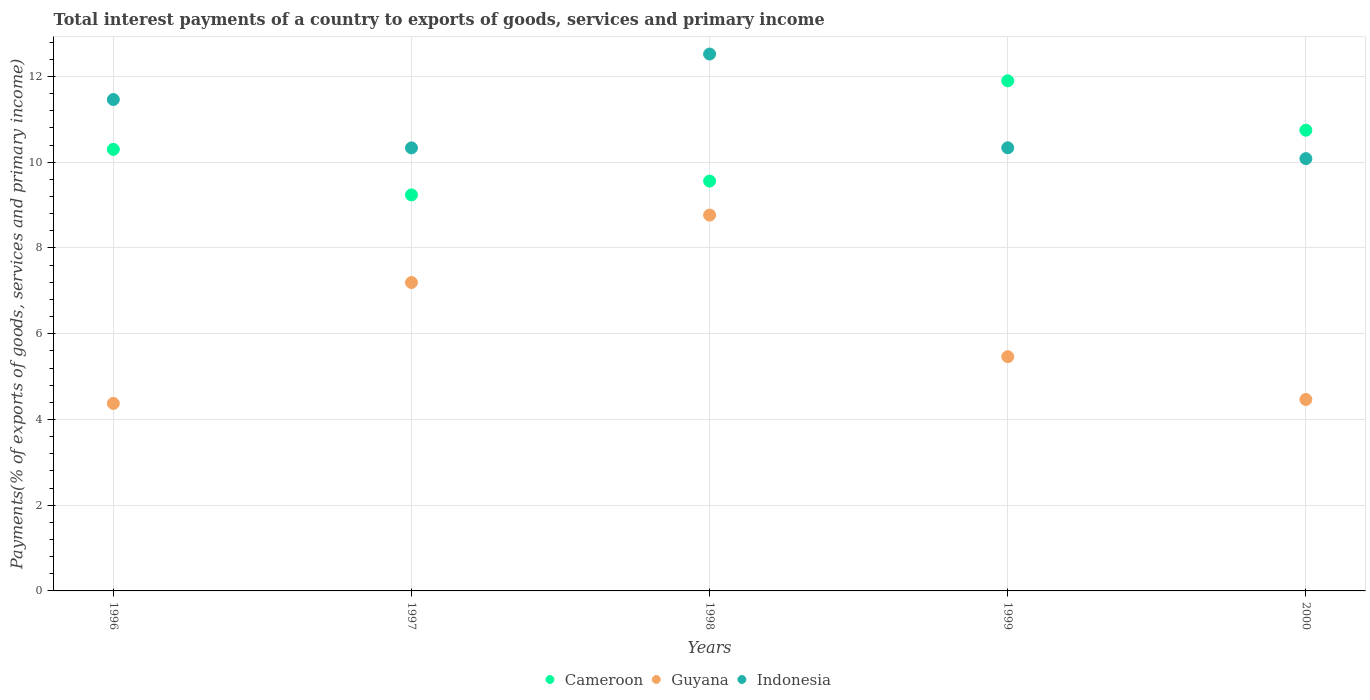How many different coloured dotlines are there?
Provide a short and direct response. 3. Is the number of dotlines equal to the number of legend labels?
Give a very brief answer. Yes. What is the total interest payments in Guyana in 2000?
Your response must be concise. 4.47. Across all years, what is the maximum total interest payments in Guyana?
Keep it short and to the point. 8.77. Across all years, what is the minimum total interest payments in Guyana?
Offer a very short reply. 4.37. What is the total total interest payments in Guyana in the graph?
Offer a very short reply. 30.27. What is the difference between the total interest payments in Indonesia in 1996 and that in 1999?
Provide a short and direct response. 1.13. What is the difference between the total interest payments in Guyana in 1998 and the total interest payments in Indonesia in 1996?
Your answer should be very brief. -2.7. What is the average total interest payments in Indonesia per year?
Your answer should be very brief. 10.95. In the year 1999, what is the difference between the total interest payments in Cameroon and total interest payments in Guyana?
Ensure brevity in your answer.  6.44. In how many years, is the total interest payments in Indonesia greater than 4 %?
Your response must be concise. 5. What is the ratio of the total interest payments in Indonesia in 1998 to that in 2000?
Keep it short and to the point. 1.24. What is the difference between the highest and the second highest total interest payments in Cameroon?
Offer a very short reply. 1.15. What is the difference between the highest and the lowest total interest payments in Indonesia?
Your response must be concise. 2.44. In how many years, is the total interest payments in Cameroon greater than the average total interest payments in Cameroon taken over all years?
Make the answer very short. 2. Is it the case that in every year, the sum of the total interest payments in Cameroon and total interest payments in Indonesia  is greater than the total interest payments in Guyana?
Offer a very short reply. Yes. Does the total interest payments in Indonesia monotonically increase over the years?
Keep it short and to the point. No. How many years are there in the graph?
Keep it short and to the point. 5. Are the values on the major ticks of Y-axis written in scientific E-notation?
Keep it short and to the point. No. Does the graph contain any zero values?
Offer a very short reply. No. How many legend labels are there?
Your answer should be compact. 3. What is the title of the graph?
Provide a succinct answer. Total interest payments of a country to exports of goods, services and primary income. What is the label or title of the Y-axis?
Offer a very short reply. Payments(% of exports of goods, services and primary income). What is the Payments(% of exports of goods, services and primary income) in Cameroon in 1996?
Provide a short and direct response. 10.3. What is the Payments(% of exports of goods, services and primary income) in Guyana in 1996?
Provide a short and direct response. 4.37. What is the Payments(% of exports of goods, services and primary income) in Indonesia in 1996?
Keep it short and to the point. 11.46. What is the Payments(% of exports of goods, services and primary income) in Cameroon in 1997?
Give a very brief answer. 9.24. What is the Payments(% of exports of goods, services and primary income) in Guyana in 1997?
Provide a short and direct response. 7.19. What is the Payments(% of exports of goods, services and primary income) of Indonesia in 1997?
Provide a short and direct response. 10.34. What is the Payments(% of exports of goods, services and primary income) of Cameroon in 1998?
Provide a succinct answer. 9.56. What is the Payments(% of exports of goods, services and primary income) in Guyana in 1998?
Your response must be concise. 8.77. What is the Payments(% of exports of goods, services and primary income) of Indonesia in 1998?
Offer a terse response. 12.52. What is the Payments(% of exports of goods, services and primary income) in Cameroon in 1999?
Provide a succinct answer. 11.9. What is the Payments(% of exports of goods, services and primary income) of Guyana in 1999?
Your answer should be very brief. 5.46. What is the Payments(% of exports of goods, services and primary income) of Indonesia in 1999?
Offer a very short reply. 10.34. What is the Payments(% of exports of goods, services and primary income) in Cameroon in 2000?
Your answer should be very brief. 10.75. What is the Payments(% of exports of goods, services and primary income) in Guyana in 2000?
Your answer should be very brief. 4.47. What is the Payments(% of exports of goods, services and primary income) in Indonesia in 2000?
Your answer should be compact. 10.08. Across all years, what is the maximum Payments(% of exports of goods, services and primary income) in Cameroon?
Give a very brief answer. 11.9. Across all years, what is the maximum Payments(% of exports of goods, services and primary income) of Guyana?
Give a very brief answer. 8.77. Across all years, what is the maximum Payments(% of exports of goods, services and primary income) in Indonesia?
Offer a terse response. 12.52. Across all years, what is the minimum Payments(% of exports of goods, services and primary income) of Cameroon?
Keep it short and to the point. 9.24. Across all years, what is the minimum Payments(% of exports of goods, services and primary income) in Guyana?
Your response must be concise. 4.37. Across all years, what is the minimum Payments(% of exports of goods, services and primary income) in Indonesia?
Make the answer very short. 10.08. What is the total Payments(% of exports of goods, services and primary income) of Cameroon in the graph?
Keep it short and to the point. 51.74. What is the total Payments(% of exports of goods, services and primary income) of Guyana in the graph?
Your answer should be very brief. 30.27. What is the total Payments(% of exports of goods, services and primary income) of Indonesia in the graph?
Give a very brief answer. 54.74. What is the difference between the Payments(% of exports of goods, services and primary income) of Cameroon in 1996 and that in 1997?
Make the answer very short. 1.06. What is the difference between the Payments(% of exports of goods, services and primary income) in Guyana in 1996 and that in 1997?
Give a very brief answer. -2.82. What is the difference between the Payments(% of exports of goods, services and primary income) in Indonesia in 1996 and that in 1997?
Your response must be concise. 1.13. What is the difference between the Payments(% of exports of goods, services and primary income) in Cameroon in 1996 and that in 1998?
Offer a very short reply. 0.74. What is the difference between the Payments(% of exports of goods, services and primary income) in Guyana in 1996 and that in 1998?
Offer a terse response. -4.39. What is the difference between the Payments(% of exports of goods, services and primary income) of Indonesia in 1996 and that in 1998?
Offer a terse response. -1.06. What is the difference between the Payments(% of exports of goods, services and primary income) of Cameroon in 1996 and that in 1999?
Give a very brief answer. -1.6. What is the difference between the Payments(% of exports of goods, services and primary income) in Guyana in 1996 and that in 1999?
Give a very brief answer. -1.09. What is the difference between the Payments(% of exports of goods, services and primary income) of Indonesia in 1996 and that in 1999?
Give a very brief answer. 1.13. What is the difference between the Payments(% of exports of goods, services and primary income) in Cameroon in 1996 and that in 2000?
Ensure brevity in your answer.  -0.45. What is the difference between the Payments(% of exports of goods, services and primary income) in Guyana in 1996 and that in 2000?
Your response must be concise. -0.09. What is the difference between the Payments(% of exports of goods, services and primary income) in Indonesia in 1996 and that in 2000?
Offer a very short reply. 1.38. What is the difference between the Payments(% of exports of goods, services and primary income) of Cameroon in 1997 and that in 1998?
Provide a succinct answer. -0.32. What is the difference between the Payments(% of exports of goods, services and primary income) in Guyana in 1997 and that in 1998?
Provide a succinct answer. -1.57. What is the difference between the Payments(% of exports of goods, services and primary income) in Indonesia in 1997 and that in 1998?
Keep it short and to the point. -2.19. What is the difference between the Payments(% of exports of goods, services and primary income) in Cameroon in 1997 and that in 1999?
Provide a succinct answer. -2.66. What is the difference between the Payments(% of exports of goods, services and primary income) in Guyana in 1997 and that in 1999?
Provide a succinct answer. 1.73. What is the difference between the Payments(% of exports of goods, services and primary income) of Indonesia in 1997 and that in 1999?
Offer a very short reply. -0. What is the difference between the Payments(% of exports of goods, services and primary income) in Cameroon in 1997 and that in 2000?
Provide a short and direct response. -1.51. What is the difference between the Payments(% of exports of goods, services and primary income) in Guyana in 1997 and that in 2000?
Your response must be concise. 2.73. What is the difference between the Payments(% of exports of goods, services and primary income) of Indonesia in 1997 and that in 2000?
Your answer should be very brief. 0.25. What is the difference between the Payments(% of exports of goods, services and primary income) of Cameroon in 1998 and that in 1999?
Offer a terse response. -2.34. What is the difference between the Payments(% of exports of goods, services and primary income) in Guyana in 1998 and that in 1999?
Give a very brief answer. 3.3. What is the difference between the Payments(% of exports of goods, services and primary income) of Indonesia in 1998 and that in 1999?
Provide a short and direct response. 2.19. What is the difference between the Payments(% of exports of goods, services and primary income) of Cameroon in 1998 and that in 2000?
Your response must be concise. -1.19. What is the difference between the Payments(% of exports of goods, services and primary income) in Guyana in 1998 and that in 2000?
Your answer should be very brief. 4.3. What is the difference between the Payments(% of exports of goods, services and primary income) of Indonesia in 1998 and that in 2000?
Offer a terse response. 2.44. What is the difference between the Payments(% of exports of goods, services and primary income) of Cameroon in 1999 and that in 2000?
Offer a terse response. 1.15. What is the difference between the Payments(% of exports of goods, services and primary income) of Guyana in 1999 and that in 2000?
Your response must be concise. 1. What is the difference between the Payments(% of exports of goods, services and primary income) in Indonesia in 1999 and that in 2000?
Keep it short and to the point. 0.25. What is the difference between the Payments(% of exports of goods, services and primary income) in Cameroon in 1996 and the Payments(% of exports of goods, services and primary income) in Guyana in 1997?
Keep it short and to the point. 3.11. What is the difference between the Payments(% of exports of goods, services and primary income) of Cameroon in 1996 and the Payments(% of exports of goods, services and primary income) of Indonesia in 1997?
Keep it short and to the point. -0.03. What is the difference between the Payments(% of exports of goods, services and primary income) in Guyana in 1996 and the Payments(% of exports of goods, services and primary income) in Indonesia in 1997?
Your answer should be very brief. -5.96. What is the difference between the Payments(% of exports of goods, services and primary income) in Cameroon in 1996 and the Payments(% of exports of goods, services and primary income) in Guyana in 1998?
Make the answer very short. 1.53. What is the difference between the Payments(% of exports of goods, services and primary income) of Cameroon in 1996 and the Payments(% of exports of goods, services and primary income) of Indonesia in 1998?
Your answer should be compact. -2.22. What is the difference between the Payments(% of exports of goods, services and primary income) in Guyana in 1996 and the Payments(% of exports of goods, services and primary income) in Indonesia in 1998?
Provide a short and direct response. -8.15. What is the difference between the Payments(% of exports of goods, services and primary income) in Cameroon in 1996 and the Payments(% of exports of goods, services and primary income) in Guyana in 1999?
Your answer should be very brief. 4.84. What is the difference between the Payments(% of exports of goods, services and primary income) in Cameroon in 1996 and the Payments(% of exports of goods, services and primary income) in Indonesia in 1999?
Your answer should be compact. -0.04. What is the difference between the Payments(% of exports of goods, services and primary income) in Guyana in 1996 and the Payments(% of exports of goods, services and primary income) in Indonesia in 1999?
Keep it short and to the point. -5.96. What is the difference between the Payments(% of exports of goods, services and primary income) in Cameroon in 1996 and the Payments(% of exports of goods, services and primary income) in Guyana in 2000?
Offer a terse response. 5.83. What is the difference between the Payments(% of exports of goods, services and primary income) of Cameroon in 1996 and the Payments(% of exports of goods, services and primary income) of Indonesia in 2000?
Give a very brief answer. 0.22. What is the difference between the Payments(% of exports of goods, services and primary income) of Guyana in 1996 and the Payments(% of exports of goods, services and primary income) of Indonesia in 2000?
Your answer should be very brief. -5.71. What is the difference between the Payments(% of exports of goods, services and primary income) in Cameroon in 1997 and the Payments(% of exports of goods, services and primary income) in Guyana in 1998?
Offer a terse response. 0.47. What is the difference between the Payments(% of exports of goods, services and primary income) in Cameroon in 1997 and the Payments(% of exports of goods, services and primary income) in Indonesia in 1998?
Your answer should be very brief. -3.29. What is the difference between the Payments(% of exports of goods, services and primary income) of Guyana in 1997 and the Payments(% of exports of goods, services and primary income) of Indonesia in 1998?
Ensure brevity in your answer.  -5.33. What is the difference between the Payments(% of exports of goods, services and primary income) in Cameroon in 1997 and the Payments(% of exports of goods, services and primary income) in Guyana in 1999?
Offer a terse response. 3.77. What is the difference between the Payments(% of exports of goods, services and primary income) in Cameroon in 1997 and the Payments(% of exports of goods, services and primary income) in Indonesia in 1999?
Provide a succinct answer. -1.1. What is the difference between the Payments(% of exports of goods, services and primary income) in Guyana in 1997 and the Payments(% of exports of goods, services and primary income) in Indonesia in 1999?
Offer a very short reply. -3.14. What is the difference between the Payments(% of exports of goods, services and primary income) in Cameroon in 1997 and the Payments(% of exports of goods, services and primary income) in Guyana in 2000?
Your answer should be compact. 4.77. What is the difference between the Payments(% of exports of goods, services and primary income) in Cameroon in 1997 and the Payments(% of exports of goods, services and primary income) in Indonesia in 2000?
Your answer should be very brief. -0.85. What is the difference between the Payments(% of exports of goods, services and primary income) in Guyana in 1997 and the Payments(% of exports of goods, services and primary income) in Indonesia in 2000?
Keep it short and to the point. -2.89. What is the difference between the Payments(% of exports of goods, services and primary income) of Cameroon in 1998 and the Payments(% of exports of goods, services and primary income) of Guyana in 1999?
Provide a short and direct response. 4.1. What is the difference between the Payments(% of exports of goods, services and primary income) in Cameroon in 1998 and the Payments(% of exports of goods, services and primary income) in Indonesia in 1999?
Your answer should be compact. -0.78. What is the difference between the Payments(% of exports of goods, services and primary income) in Guyana in 1998 and the Payments(% of exports of goods, services and primary income) in Indonesia in 1999?
Provide a succinct answer. -1.57. What is the difference between the Payments(% of exports of goods, services and primary income) in Cameroon in 1998 and the Payments(% of exports of goods, services and primary income) in Guyana in 2000?
Your response must be concise. 5.09. What is the difference between the Payments(% of exports of goods, services and primary income) of Cameroon in 1998 and the Payments(% of exports of goods, services and primary income) of Indonesia in 2000?
Your response must be concise. -0.52. What is the difference between the Payments(% of exports of goods, services and primary income) of Guyana in 1998 and the Payments(% of exports of goods, services and primary income) of Indonesia in 2000?
Give a very brief answer. -1.32. What is the difference between the Payments(% of exports of goods, services and primary income) of Cameroon in 1999 and the Payments(% of exports of goods, services and primary income) of Guyana in 2000?
Make the answer very short. 7.43. What is the difference between the Payments(% of exports of goods, services and primary income) in Cameroon in 1999 and the Payments(% of exports of goods, services and primary income) in Indonesia in 2000?
Your answer should be very brief. 1.81. What is the difference between the Payments(% of exports of goods, services and primary income) of Guyana in 1999 and the Payments(% of exports of goods, services and primary income) of Indonesia in 2000?
Make the answer very short. -4.62. What is the average Payments(% of exports of goods, services and primary income) in Cameroon per year?
Your answer should be very brief. 10.35. What is the average Payments(% of exports of goods, services and primary income) of Guyana per year?
Give a very brief answer. 6.05. What is the average Payments(% of exports of goods, services and primary income) in Indonesia per year?
Your answer should be compact. 10.95. In the year 1996, what is the difference between the Payments(% of exports of goods, services and primary income) in Cameroon and Payments(% of exports of goods, services and primary income) in Guyana?
Your response must be concise. 5.93. In the year 1996, what is the difference between the Payments(% of exports of goods, services and primary income) of Cameroon and Payments(% of exports of goods, services and primary income) of Indonesia?
Give a very brief answer. -1.16. In the year 1996, what is the difference between the Payments(% of exports of goods, services and primary income) in Guyana and Payments(% of exports of goods, services and primary income) in Indonesia?
Offer a terse response. -7.09. In the year 1997, what is the difference between the Payments(% of exports of goods, services and primary income) in Cameroon and Payments(% of exports of goods, services and primary income) in Guyana?
Your answer should be very brief. 2.04. In the year 1997, what is the difference between the Payments(% of exports of goods, services and primary income) of Cameroon and Payments(% of exports of goods, services and primary income) of Indonesia?
Offer a very short reply. -1.1. In the year 1997, what is the difference between the Payments(% of exports of goods, services and primary income) in Guyana and Payments(% of exports of goods, services and primary income) in Indonesia?
Your response must be concise. -3.14. In the year 1998, what is the difference between the Payments(% of exports of goods, services and primary income) of Cameroon and Payments(% of exports of goods, services and primary income) of Guyana?
Your answer should be very brief. 0.79. In the year 1998, what is the difference between the Payments(% of exports of goods, services and primary income) of Cameroon and Payments(% of exports of goods, services and primary income) of Indonesia?
Ensure brevity in your answer.  -2.96. In the year 1998, what is the difference between the Payments(% of exports of goods, services and primary income) of Guyana and Payments(% of exports of goods, services and primary income) of Indonesia?
Offer a very short reply. -3.76. In the year 1999, what is the difference between the Payments(% of exports of goods, services and primary income) of Cameroon and Payments(% of exports of goods, services and primary income) of Guyana?
Provide a succinct answer. 6.44. In the year 1999, what is the difference between the Payments(% of exports of goods, services and primary income) of Cameroon and Payments(% of exports of goods, services and primary income) of Indonesia?
Make the answer very short. 1.56. In the year 1999, what is the difference between the Payments(% of exports of goods, services and primary income) in Guyana and Payments(% of exports of goods, services and primary income) in Indonesia?
Offer a terse response. -4.87. In the year 2000, what is the difference between the Payments(% of exports of goods, services and primary income) in Cameroon and Payments(% of exports of goods, services and primary income) in Guyana?
Provide a succinct answer. 6.28. In the year 2000, what is the difference between the Payments(% of exports of goods, services and primary income) of Cameroon and Payments(% of exports of goods, services and primary income) of Indonesia?
Give a very brief answer. 0.66. In the year 2000, what is the difference between the Payments(% of exports of goods, services and primary income) of Guyana and Payments(% of exports of goods, services and primary income) of Indonesia?
Make the answer very short. -5.62. What is the ratio of the Payments(% of exports of goods, services and primary income) of Cameroon in 1996 to that in 1997?
Keep it short and to the point. 1.11. What is the ratio of the Payments(% of exports of goods, services and primary income) in Guyana in 1996 to that in 1997?
Offer a terse response. 0.61. What is the ratio of the Payments(% of exports of goods, services and primary income) of Indonesia in 1996 to that in 1997?
Keep it short and to the point. 1.11. What is the ratio of the Payments(% of exports of goods, services and primary income) in Cameroon in 1996 to that in 1998?
Ensure brevity in your answer.  1.08. What is the ratio of the Payments(% of exports of goods, services and primary income) in Guyana in 1996 to that in 1998?
Give a very brief answer. 0.5. What is the ratio of the Payments(% of exports of goods, services and primary income) of Indonesia in 1996 to that in 1998?
Provide a succinct answer. 0.92. What is the ratio of the Payments(% of exports of goods, services and primary income) in Cameroon in 1996 to that in 1999?
Keep it short and to the point. 0.87. What is the ratio of the Payments(% of exports of goods, services and primary income) in Guyana in 1996 to that in 1999?
Make the answer very short. 0.8. What is the ratio of the Payments(% of exports of goods, services and primary income) in Indonesia in 1996 to that in 1999?
Give a very brief answer. 1.11. What is the ratio of the Payments(% of exports of goods, services and primary income) of Cameroon in 1996 to that in 2000?
Your response must be concise. 0.96. What is the ratio of the Payments(% of exports of goods, services and primary income) in Guyana in 1996 to that in 2000?
Your response must be concise. 0.98. What is the ratio of the Payments(% of exports of goods, services and primary income) of Indonesia in 1996 to that in 2000?
Your answer should be very brief. 1.14. What is the ratio of the Payments(% of exports of goods, services and primary income) in Cameroon in 1997 to that in 1998?
Provide a short and direct response. 0.97. What is the ratio of the Payments(% of exports of goods, services and primary income) in Guyana in 1997 to that in 1998?
Keep it short and to the point. 0.82. What is the ratio of the Payments(% of exports of goods, services and primary income) in Indonesia in 1997 to that in 1998?
Ensure brevity in your answer.  0.83. What is the ratio of the Payments(% of exports of goods, services and primary income) in Cameroon in 1997 to that in 1999?
Your answer should be very brief. 0.78. What is the ratio of the Payments(% of exports of goods, services and primary income) of Guyana in 1997 to that in 1999?
Your response must be concise. 1.32. What is the ratio of the Payments(% of exports of goods, services and primary income) of Cameroon in 1997 to that in 2000?
Keep it short and to the point. 0.86. What is the ratio of the Payments(% of exports of goods, services and primary income) in Guyana in 1997 to that in 2000?
Make the answer very short. 1.61. What is the ratio of the Payments(% of exports of goods, services and primary income) of Indonesia in 1997 to that in 2000?
Keep it short and to the point. 1.02. What is the ratio of the Payments(% of exports of goods, services and primary income) of Cameroon in 1998 to that in 1999?
Provide a succinct answer. 0.8. What is the ratio of the Payments(% of exports of goods, services and primary income) in Guyana in 1998 to that in 1999?
Give a very brief answer. 1.6. What is the ratio of the Payments(% of exports of goods, services and primary income) in Indonesia in 1998 to that in 1999?
Offer a terse response. 1.21. What is the ratio of the Payments(% of exports of goods, services and primary income) in Cameroon in 1998 to that in 2000?
Your answer should be very brief. 0.89. What is the ratio of the Payments(% of exports of goods, services and primary income) in Guyana in 1998 to that in 2000?
Ensure brevity in your answer.  1.96. What is the ratio of the Payments(% of exports of goods, services and primary income) of Indonesia in 1998 to that in 2000?
Make the answer very short. 1.24. What is the ratio of the Payments(% of exports of goods, services and primary income) of Cameroon in 1999 to that in 2000?
Ensure brevity in your answer.  1.11. What is the ratio of the Payments(% of exports of goods, services and primary income) of Guyana in 1999 to that in 2000?
Your response must be concise. 1.22. What is the ratio of the Payments(% of exports of goods, services and primary income) of Indonesia in 1999 to that in 2000?
Give a very brief answer. 1.02. What is the difference between the highest and the second highest Payments(% of exports of goods, services and primary income) in Cameroon?
Your answer should be compact. 1.15. What is the difference between the highest and the second highest Payments(% of exports of goods, services and primary income) of Guyana?
Your answer should be very brief. 1.57. What is the difference between the highest and the second highest Payments(% of exports of goods, services and primary income) in Indonesia?
Keep it short and to the point. 1.06. What is the difference between the highest and the lowest Payments(% of exports of goods, services and primary income) of Cameroon?
Provide a succinct answer. 2.66. What is the difference between the highest and the lowest Payments(% of exports of goods, services and primary income) in Guyana?
Your answer should be very brief. 4.39. What is the difference between the highest and the lowest Payments(% of exports of goods, services and primary income) of Indonesia?
Offer a very short reply. 2.44. 